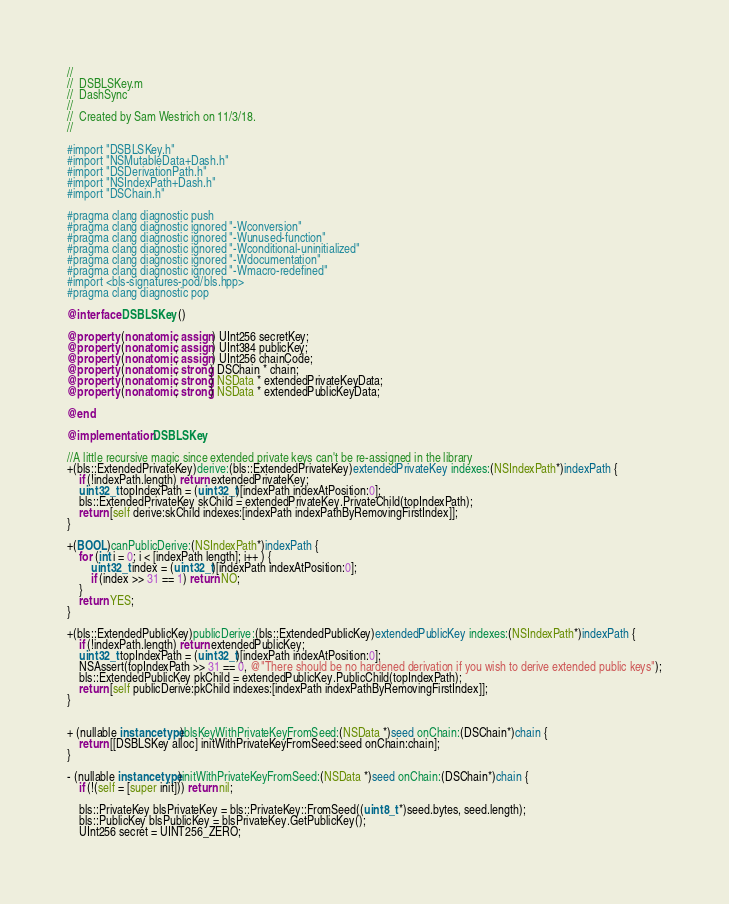Convert code to text. <code><loc_0><loc_0><loc_500><loc_500><_ObjectiveC_>//
//  DSBLSKey.m
//  DashSync
//
//  Created by Sam Westrich on 11/3/18.
//

#import "DSBLSKey.h"
#import "NSMutableData+Dash.h"
#import "DSDerivationPath.h"
#import "NSIndexPath+Dash.h"
#import "DSChain.h"

#pragma clang diagnostic push
#pragma clang diagnostic ignored "-Wconversion"
#pragma clang diagnostic ignored "-Wunused-function"
#pragma clang diagnostic ignored "-Wconditional-uninitialized"
#pragma clang diagnostic ignored "-Wdocumentation"
#pragma clang diagnostic ignored "-Wmacro-redefined"
#import <bls-signatures-pod/bls.hpp>
#pragma clang diagnostic pop

@interface DSBLSKey ()

@property (nonatomic, assign) UInt256 secretKey;
@property (nonatomic, assign) UInt384 publicKey;
@property (nonatomic, assign) UInt256 chainCode;
@property (nonatomic, strong) DSChain * chain;
@property (nonatomic, strong) NSData * extendedPrivateKeyData;
@property (nonatomic, strong) NSData * extendedPublicKeyData;

@end

@implementation DSBLSKey

//A little recursive magic since extended private keys can't be re-assigned in the library
+(bls::ExtendedPrivateKey)derive:(bls::ExtendedPrivateKey)extendedPrivateKey indexes:(NSIndexPath*)indexPath {
    if (!indexPath.length) return extendedPrivateKey;
    uint32_t topIndexPath = (uint32_t)[indexPath indexAtPosition:0];
    bls::ExtendedPrivateKey skChild = extendedPrivateKey.PrivateChild(topIndexPath);
    return [self derive:skChild indexes:[indexPath indexPathByRemovingFirstIndex]];
}

+(BOOL)canPublicDerive:(NSIndexPath*)indexPath {
    for (int i = 0; i < [indexPath length]; i++ ) {
        uint32_t index = (uint32_t)[indexPath indexAtPosition:0];
        if (index >> 31 == 1) return NO;
    }
    return YES;
}

+(bls::ExtendedPublicKey)publicDerive:(bls::ExtendedPublicKey)extendedPublicKey indexes:(NSIndexPath*)indexPath {
    if (!indexPath.length) return extendedPublicKey;
    uint32_t topIndexPath = (uint32_t)[indexPath indexAtPosition:0];
    NSAssert(topIndexPath >> 31 == 0, @"There should be no hardened derivation if you wish to derive extended public keys");
    bls::ExtendedPublicKey pkChild = extendedPublicKey.PublicChild(topIndexPath);
    return [self publicDerive:pkChild indexes:[indexPath indexPathByRemovingFirstIndex]];
}


+ (nullable instancetype)blsKeyWithPrivateKeyFromSeed:(NSData *)seed onChain:(DSChain*)chain {
    return [[DSBLSKey alloc] initWithPrivateKeyFromSeed:seed onChain:chain];
}

- (nullable instancetype)initWithPrivateKeyFromSeed:(NSData *)seed onChain:(DSChain*)chain {
    if (!(self = [super init])) return nil;
    
    bls::PrivateKey blsPrivateKey = bls::PrivateKey::FromSeed((uint8_t *)seed.bytes, seed.length);
    bls::PublicKey blsPublicKey = blsPrivateKey.GetPublicKey();
    UInt256 secret = UINT256_ZERO;</code> 